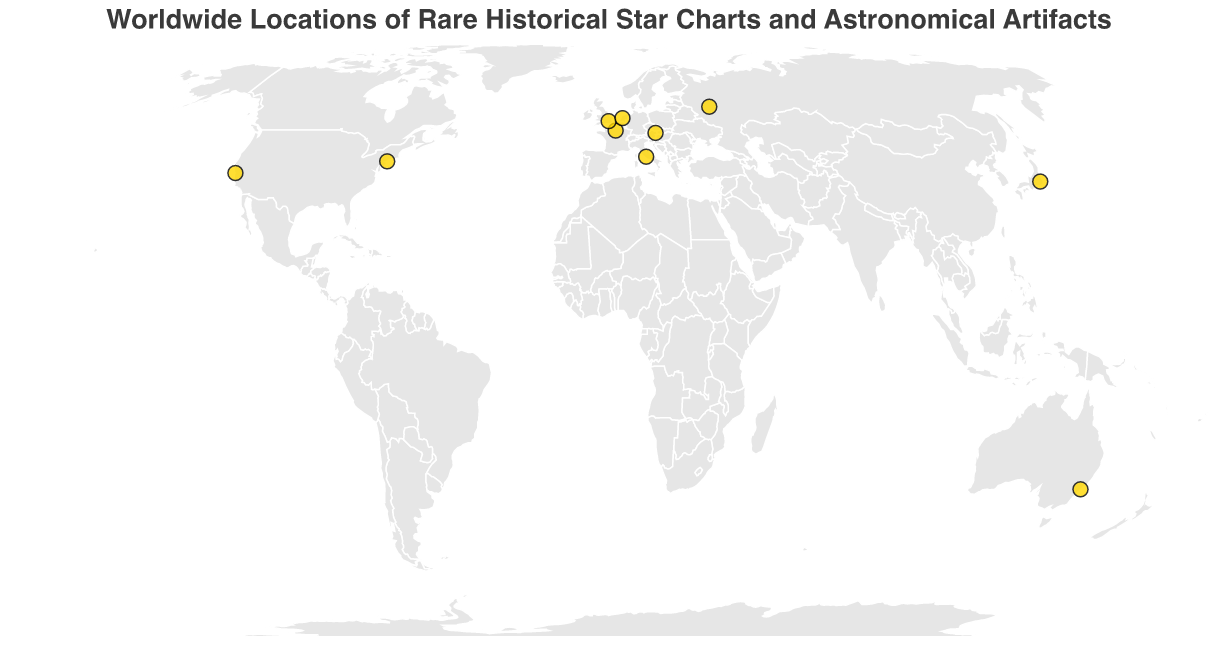What's the title of the figure? Reading the title text positioned at the top of the figure, we can identify the title as "Worldwide Locations of Rare Historical Star Charts and Astronomical Artifacts."
Answer: Worldwide Locations of Rare Historical Star Charts and Astronomical Artifacts How many locations are depicted on the map? By counting the number of circles on the map, we can determine that there are 10 distinct locations shown on the map.
Answer: 10 Which location houses the oldest artifact shown on the map? Observing the tooltips and data points, we identify "Al-Sufi's Book of Fixed Stars" at the "California Academy of Sciences" dated 964 as the oldest artifact.
Answer: California Academy of Sciences What is the artifact showcased at the National Museum of Nature and Science Tokyo, and from which year? By checking the tooltip for the data point at Tokyo's coordinates, we find the artifact is the "Dunhuang Star Chart" from the year 700.
Answer: Dunhuang Star Chart, 700 Which cities have artifacts dated before the 17th century? Reviewing the tooltips for all data points and noting down those with years before 1600, we find the artifacts in "Kunsthistorisches Museum Vienna" (1515), "California Academy of Sciences" (964), "National Museum of Nature and Science Tokyo" (700), and "Rijksmuseum Amsterdam" (1602).
Answer: Vienna, San Francisco, Tokyo, Amsterdam Which artifact is the most recent in the dataset? Checking the years on all tooltips, we identify "John Bevis’s Uranographia Britannica" at the "Sydney Observatory" dated 1750 as the most recent artifact in the dataset.
Answer: John Bevis's Uranographia Britannica in Sydney Observatory Compare the number of artifacts from the 17th century to those from the 18th century. Which century has more artifacts? Counting entries for each century, there are 4 artifacts from the 17th century (1603, 1602, 1687, 1693) and 2 artifacts from the 18th century (1729, 1750).
Answer: 17th century Which location is the farthest south on the map? By comparing the latitude values for all locations, we see that the "Sydney Observatory" with a latitude of -33.8688 is the farthest south.
Answer: Sydney Observatory How many artifacts are listed from European locations? Counting the data points in European coordinates (Paris, London, Moscow, Vatican City, Amsterdam, Vienna), we find there are six artifacts listed from European locations.
Answer: 6 What is the average year of the artifacts displayed? Summing the years and dividing by the number of artifacts: (1729 + 1603 + 1687 + 1693 + 1661 + 700 + 1602 + 1750 + 964 + 1515) / 10 = 14294 / 10 = 1429.4.
Answer: 1429.4 